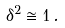Convert formula to latex. <formula><loc_0><loc_0><loc_500><loc_500>\delta ^ { 2 } \cong 1 \, .</formula> 